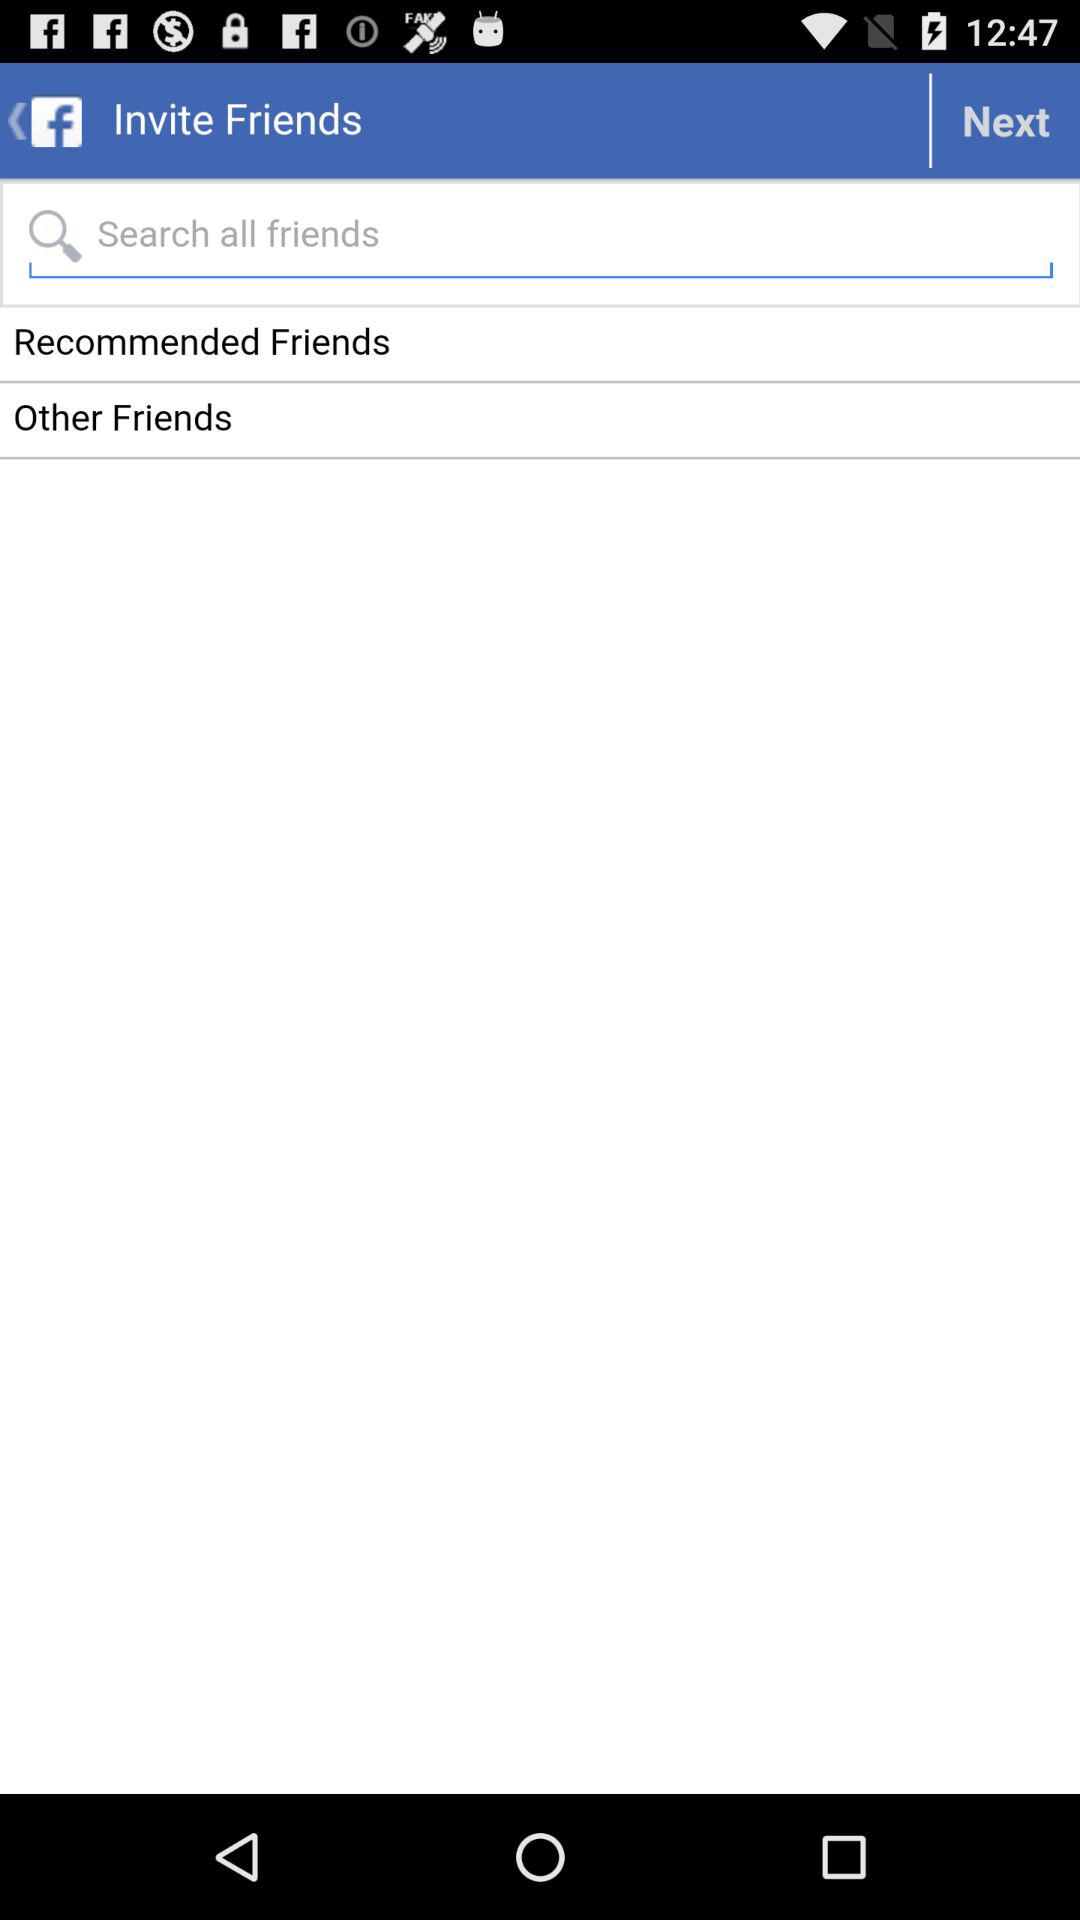Through which application can we invite Facebook friends?
When the provided information is insufficient, respond with <no answer>. <no answer> 